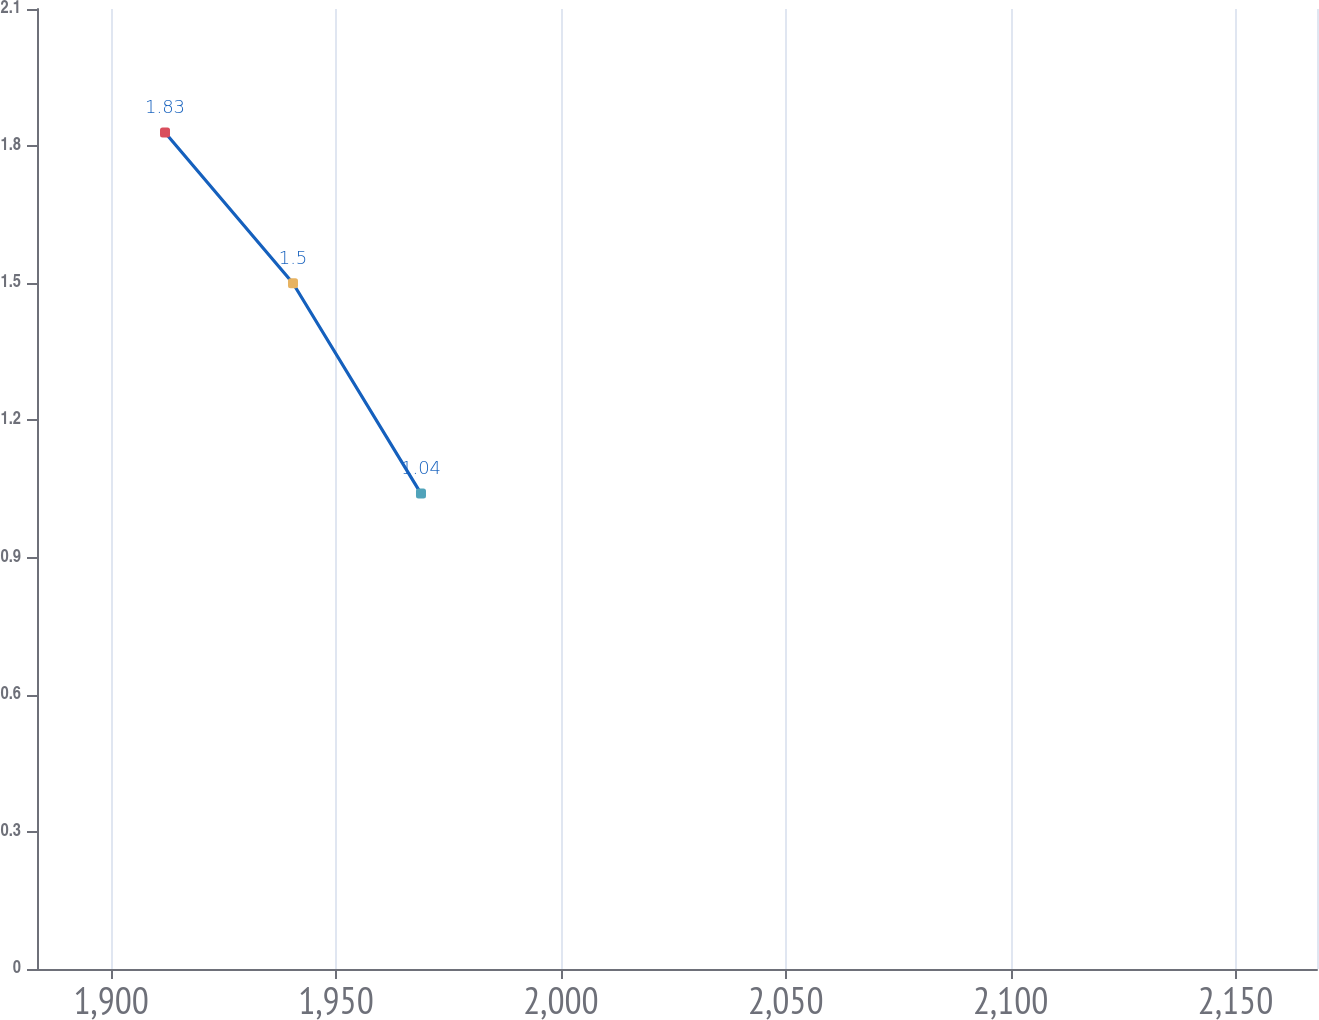Convert chart. <chart><loc_0><loc_0><loc_500><loc_500><line_chart><ecel><fcel>$7.3<nl><fcel>1911.96<fcel>1.83<nl><fcel>1940.42<fcel>1.5<nl><fcel>1968.88<fcel>1.04<nl><fcel>2196.57<fcel>1.14<nl></chart> 